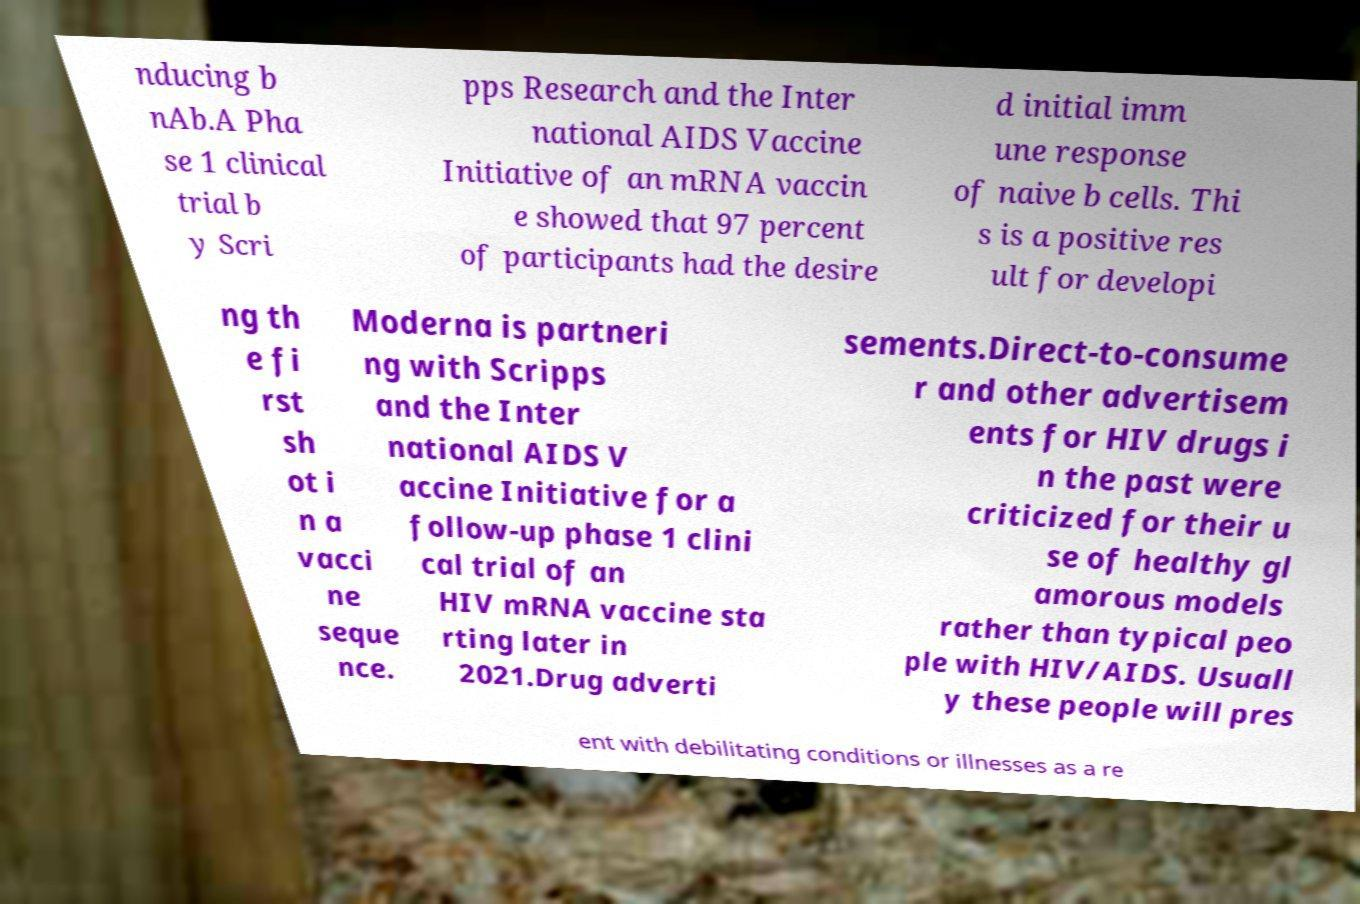For documentation purposes, I need the text within this image transcribed. Could you provide that? nducing b nAb.A Pha se 1 clinical trial b y Scri pps Research and the Inter national AIDS Vaccine Initiative of an mRNA vaccin e showed that 97 percent of participants had the desire d initial imm une response of naive b cells. Thi s is a positive res ult for developi ng th e fi rst sh ot i n a vacci ne seque nce. Moderna is partneri ng with Scripps and the Inter national AIDS V accine Initiative for a follow-up phase 1 clini cal trial of an HIV mRNA vaccine sta rting later in 2021.Drug adverti sements.Direct-to-consume r and other advertisem ents for HIV drugs i n the past were criticized for their u se of healthy gl amorous models rather than typical peo ple with HIV/AIDS. Usuall y these people will pres ent with debilitating conditions or illnesses as a re 